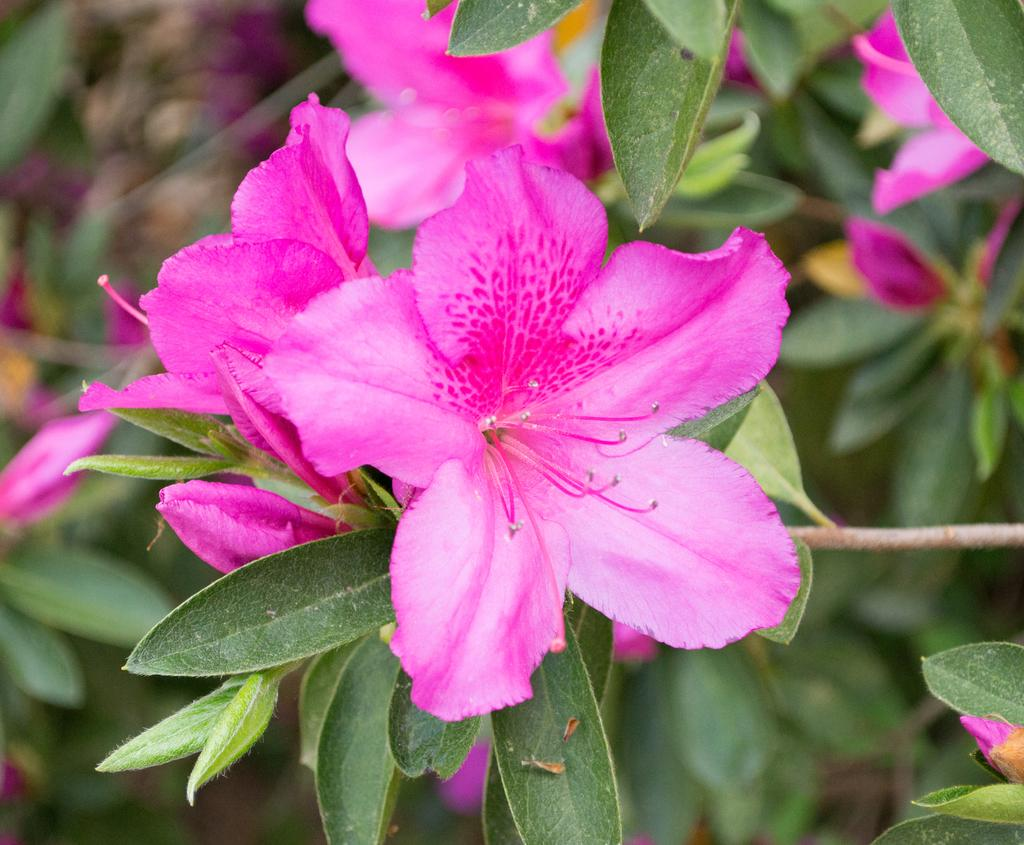What type of living organisms can be seen in the image? There are flowers in the image. Where are the flowers located? The flowers are on plants. What color are the flowers? The flowers are pink in color. What type of flesh can be seen on the rail in the image? There is no rail or flesh present in the image; it features flowers on plants. 